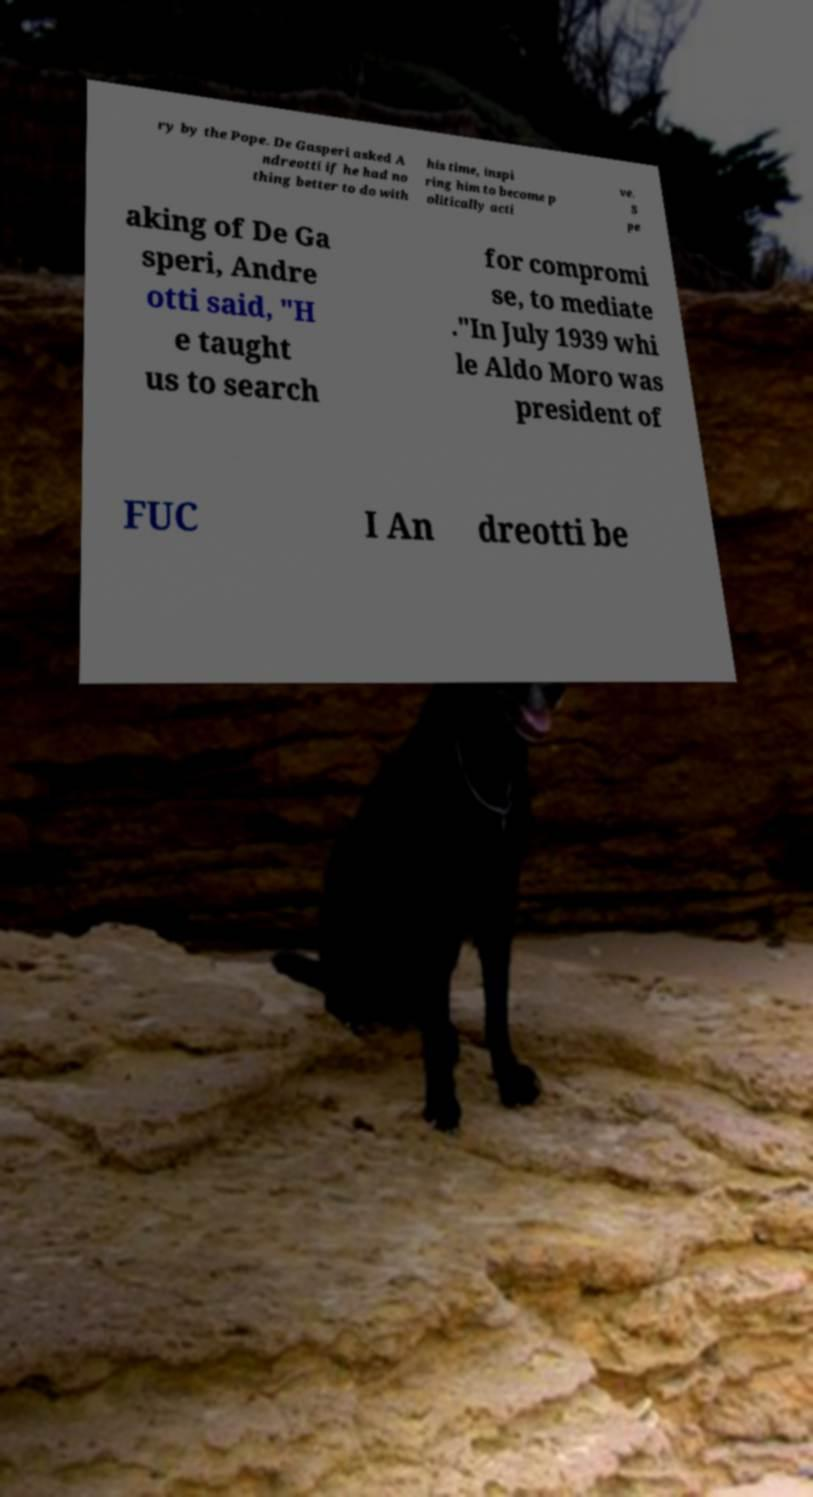Please identify and transcribe the text found in this image. ry by the Pope. De Gasperi asked A ndreotti if he had no thing better to do with his time, inspi ring him to become p olitically acti ve. S pe aking of De Ga speri, Andre otti said, "H e taught us to search for compromi se, to mediate ."In July 1939 whi le Aldo Moro was president of FUC I An dreotti be 